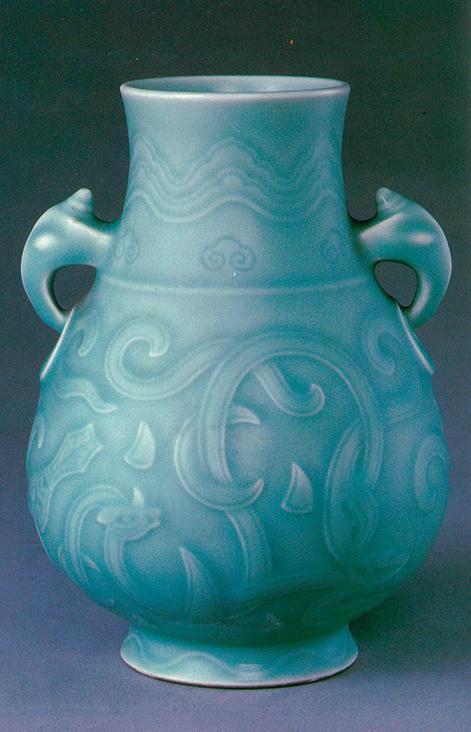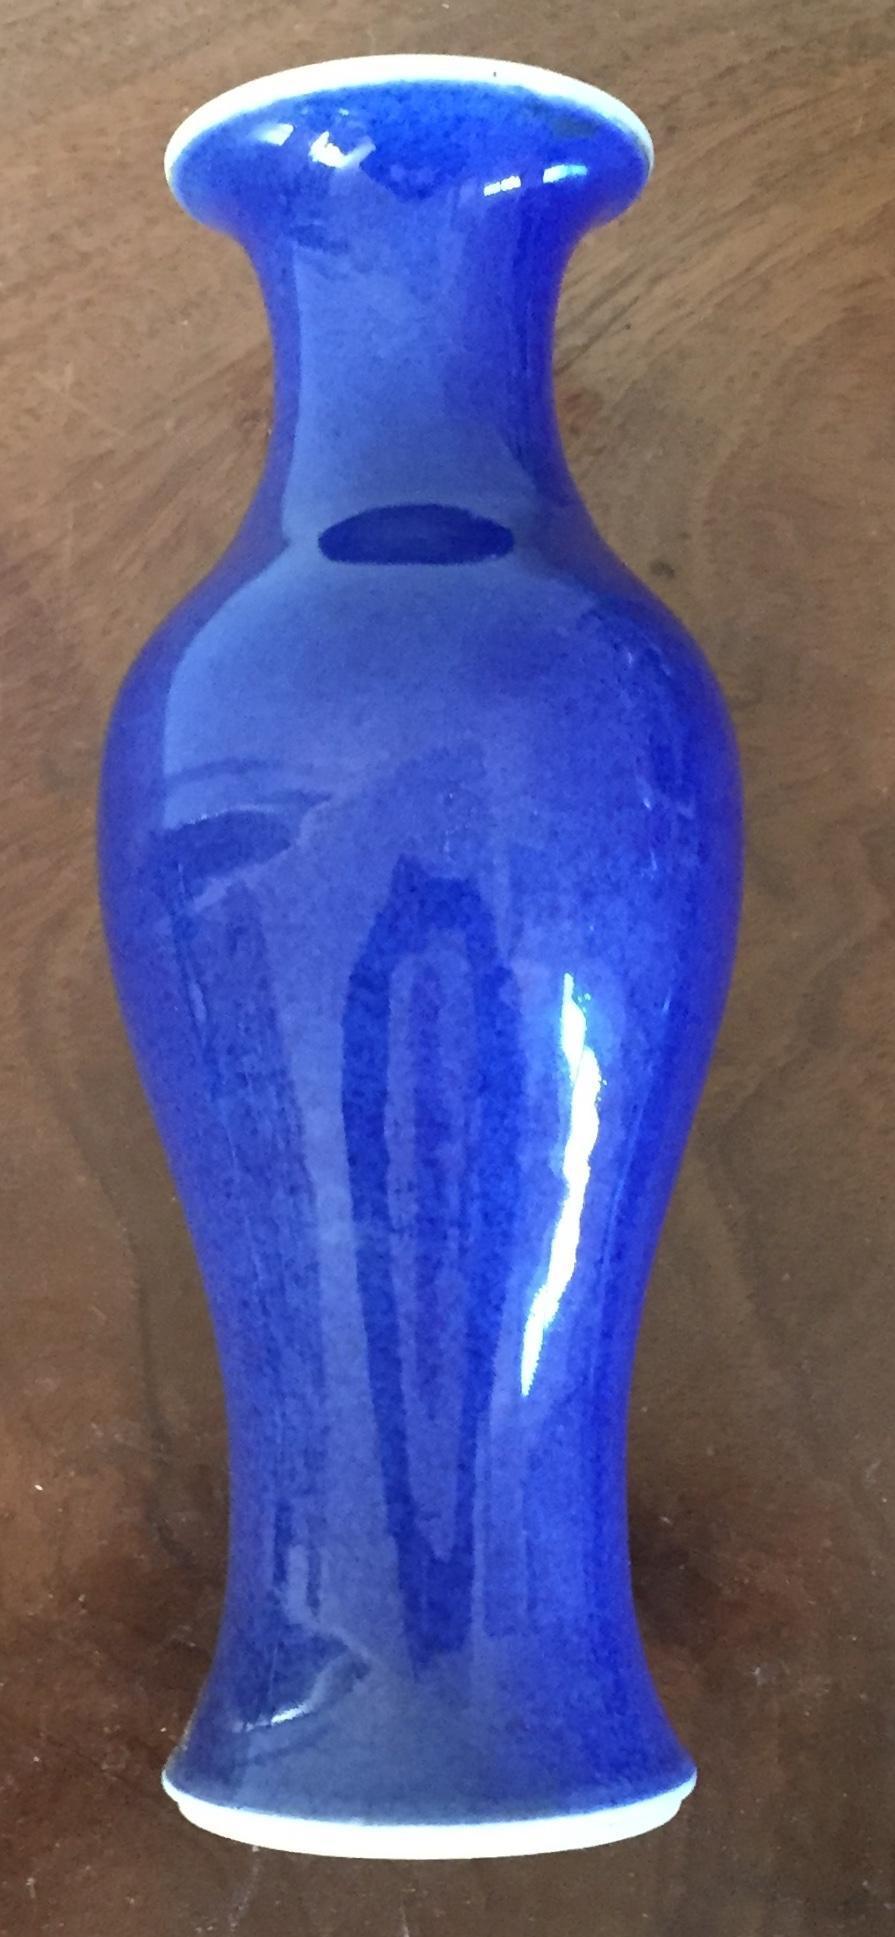The first image is the image on the left, the second image is the image on the right. Given the left and right images, does the statement "One of the images shows a purple vase while the vase in the other image is mostly blue." hold true? Answer yes or no. No. The first image is the image on the left, the second image is the image on the right. Evaluate the accuracy of this statement regarding the images: "A solid blue vase with no markings or texture is in in the right image.". Is it true? Answer yes or no. Yes. 